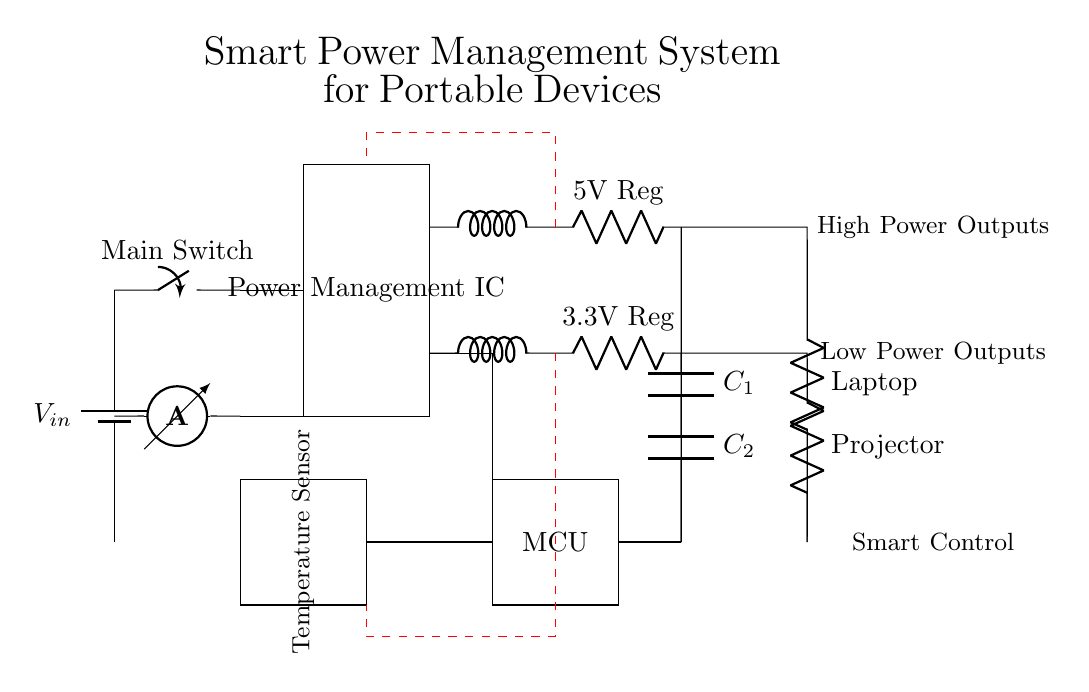What is the main power source in this circuit? The main power source is represented by the battery symbol labeled as V_in. This component provides the necessary voltage for the rest of the circuit to function.
Answer: V_in What type of device is connected to the 5V regulator? The component connected to the 5V regulator is labeled as Laptop. This indicates that the laptop receives power regulated to 5 volts from the circuit.
Answer: Laptop How many voltage regulators are present in the circuit? There are two voltage regulators shown in the circuit diagram, one labeled for 5V and another for 3.3V. Each is responsible for providing a specific voltage output to the connected loads.
Answer: Two What is the function of the Power Management IC? The Power Management IC is a critical component that distributes power efficiently to different parts of the circuit, ensuring that each load receives the appropriate voltage while managing power consumption.
Answer: Distributes power Which sensors are included in the circuit? The temperature sensor is included in the circuit, as indicated by its labeled rectangle. This component is likely used to monitor temperature for power management purposes.
Answer: Temperature Sensor What role does the microcontroller play in this circuit? The microcontroller coordinates the operation of the circuit by controlling the Power Management IC and monitoring the performance of the sensors to optimize power distribution and efficiency.
Answer: Coordinate operations What feedback loops are indicated in the circuit? The feedback loops are illustrated with red dashed lines, showing connections that monitor variations in output voltages from the regulators to ensure they remain stable and within desired limits.
Answer: Output voltage stabilization 